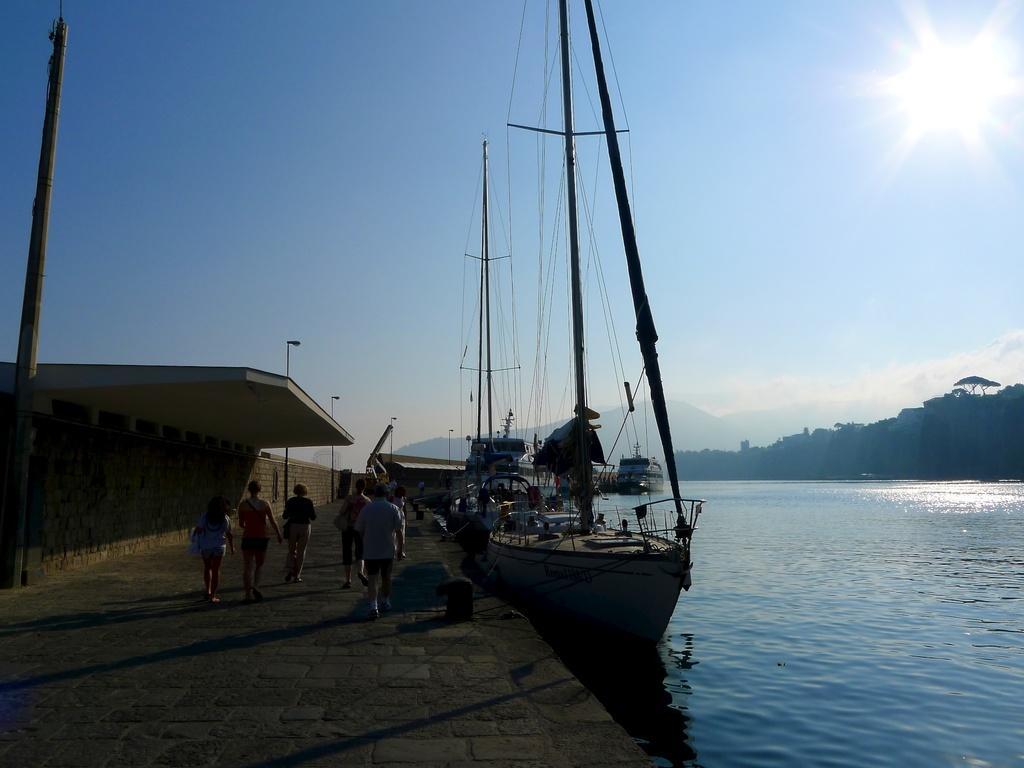Describe this image in one or two sentences. In this image there are people walking on a pavement, beside the pavement there are ships on a river, in the background there are trees mountain and the sky. 